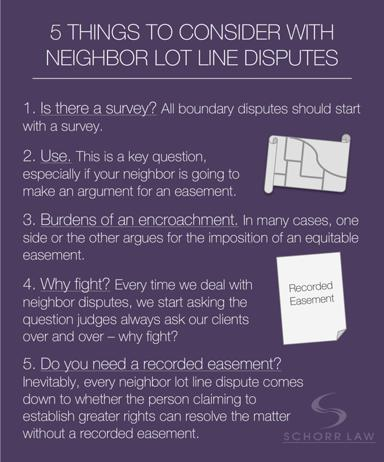What is the main topic discussed in the text? The text primarily focuses on "5 Things to Consider with Neighbor Lot Line Disputes." It provides a structured outline to guide individuals through the complexities of resolving boundary disputes with neighbors. 